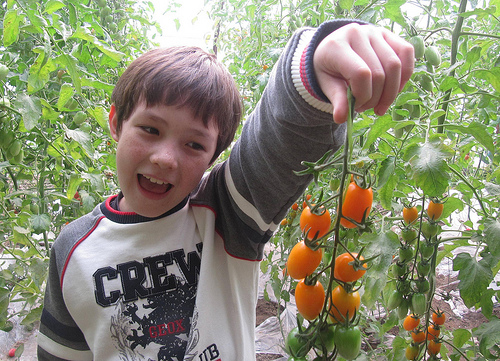<image>
Is the tomato behind the tomato? No. The tomato is not behind the tomato. From this viewpoint, the tomato appears to be positioned elsewhere in the scene. Is there a roma tomatoes next to the boy? Yes. The roma tomatoes is positioned adjacent to the boy, located nearby in the same general area. 